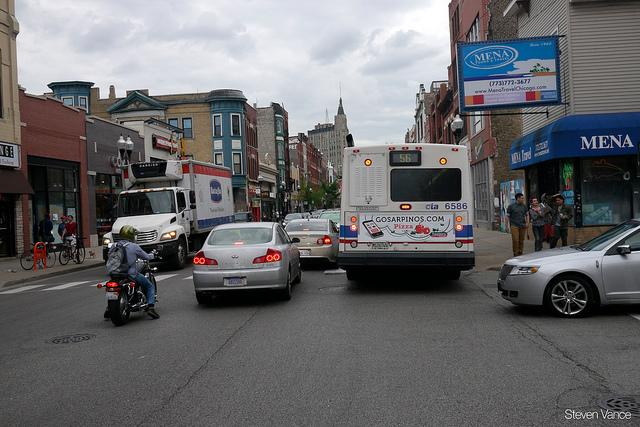Which vehicle stuck in the intersection is in the most danger? Please explain your reasoning. motorcycle. The cyclist has less to protect him than the cars on the road. 